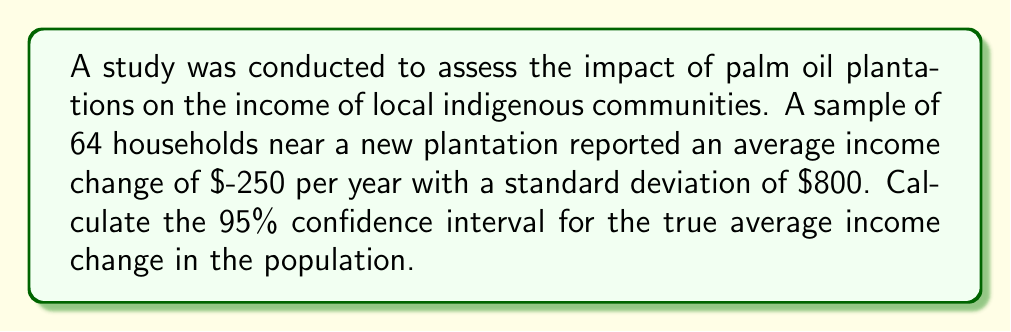Give your solution to this math problem. To calculate the confidence interval, we'll follow these steps:

1) The formula for a confidence interval is:

   $$\bar{x} \pm t_{\alpha/2} \cdot \frac{s}{\sqrt{n}}$$

   Where:
   $\bar{x}$ is the sample mean
   $t_{\alpha/2}$ is the t-value for the desired confidence level
   $s$ is the sample standard deviation
   $n$ is the sample size

2) We know:
   $\bar{x} = -250$
   $s = 800$
   $n = 64$
   Confidence level = 95%, so $\alpha = 0.05$

3) For a 95% confidence interval with 63 degrees of freedom (n-1), the t-value is approximately 2.000.

4) Now, let's substitute these values into our formula:

   $$-250 \pm 2.000 \cdot \frac{800}{\sqrt{64}}$$

5) Simplify:
   $$-250 \pm 2.000 \cdot \frac{800}{8} = -250 \pm 2.000 \cdot 100 = -250 \pm 200$$

6) Therefore, the confidence interval is:
   $$(-450, -50)$$

This means we can be 95% confident that the true average income change for the population is between a decrease of $450 and a decrease of $50 per year.
Answer: (-$450, -$50) 